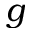Convert formula to latex. <formula><loc_0><loc_0><loc_500><loc_500>g</formula> 